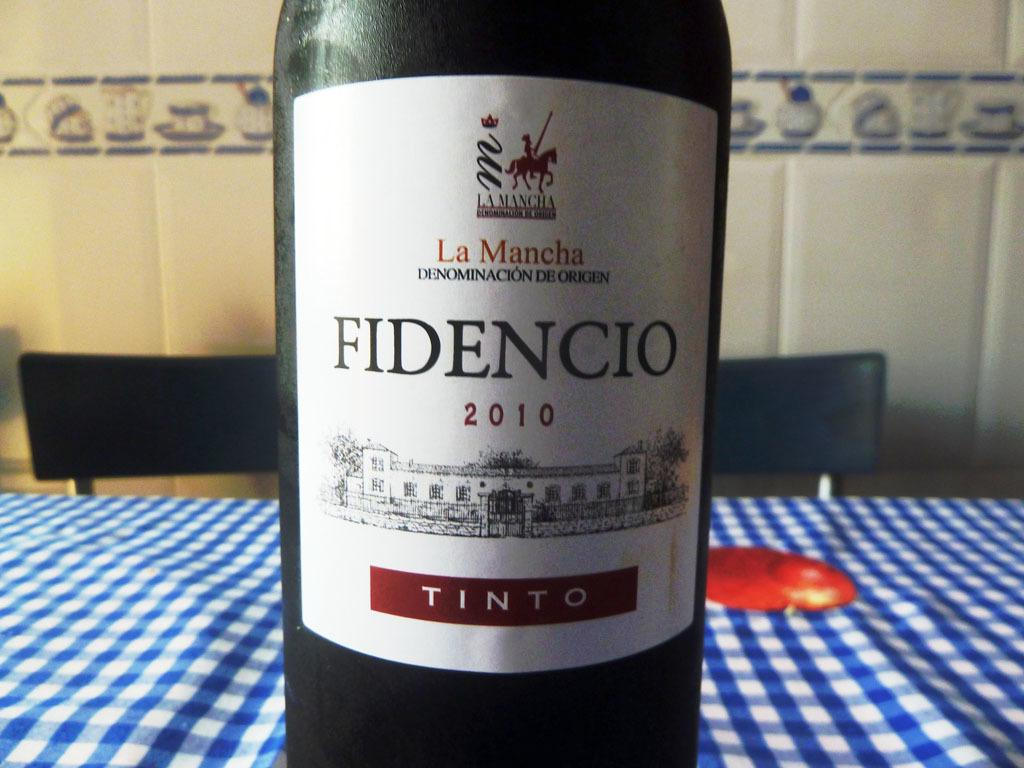Provide a one-sentence caption for the provided image. A bottle of Fidencio wine is on the table. 